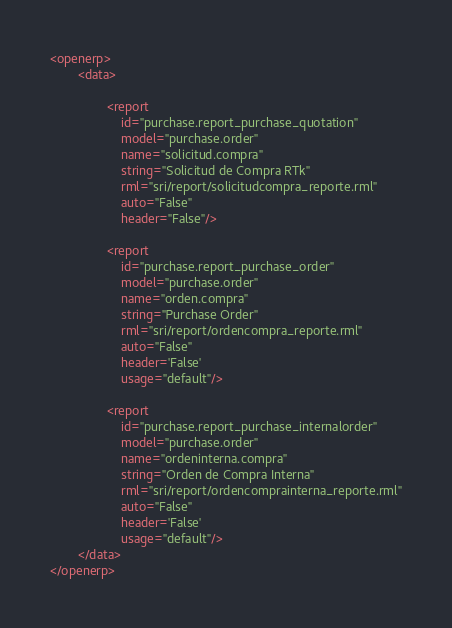Convert code to text. <code><loc_0><loc_0><loc_500><loc_500><_XML_><openerp>
        <data>
        		
                <report
                    id="purchase.report_purchase_quotation"
                    model="purchase.order"
                    name="solicitud.compra"
                    string="Solicitud de Compra RTk"
                    rml="sri/report/solicitudcompra_reporte.rml"
                    auto="False"
                    header="False"/>
                        
				<report
					id="purchase.report_purchase_order" 
					model="purchase.order"
                	name="orden.compra"
                	string="Purchase Order" 
                	rml="sri/report/ordencompra_reporte.rml"
                	auto="False"
                	header='False'
                	usage="default"/>
                	
                <report
					id="purchase.report_purchase_internalorder" 
					model="purchase.order"
                	name="ordeninterna.compra"
                	string="Orden de Compra Interna" 
                	rml="sri/report/ordencomprainterna_reporte.rml"
                	auto="False"
                	header='False'
                	usage="default"/>
        </data>
</openerp>
</code> 